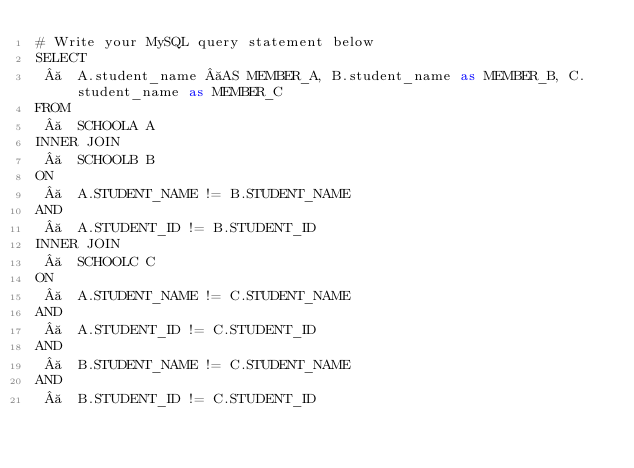<code> <loc_0><loc_0><loc_500><loc_500><_SQL_># Write your MySQL query statement below
SELECT
    A.student_name  AS MEMBER_A, B.student_name as MEMBER_B, C.student_name as MEMBER_C
FROM
    SCHOOLA A
INNER JOIN
    SCHOOLB B
ON
    A.STUDENT_NAME != B.STUDENT_NAME
AND
    A.STUDENT_ID != B.STUDENT_ID
INNER JOIN
    SCHOOLC C
ON
    A.STUDENT_NAME != C.STUDENT_NAME
AND
    A.STUDENT_ID != C.STUDENT_ID
AND
    B.STUDENT_NAME != C.STUDENT_NAME
AND
    B.STUDENT_ID != C.STUDENT_ID
</code> 